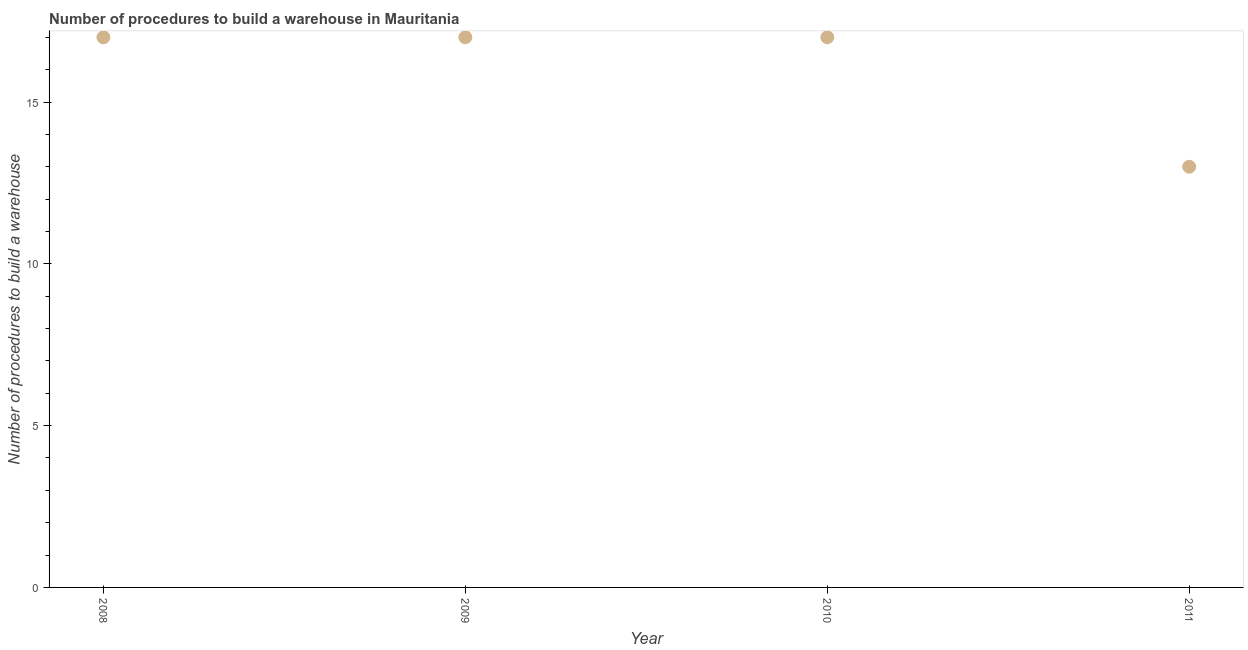What is the number of procedures to build a warehouse in 2009?
Offer a very short reply. 17. Across all years, what is the maximum number of procedures to build a warehouse?
Your answer should be compact. 17. Across all years, what is the minimum number of procedures to build a warehouse?
Offer a very short reply. 13. What is the sum of the number of procedures to build a warehouse?
Your response must be concise. 64. What is the difference between the number of procedures to build a warehouse in 2008 and 2010?
Offer a very short reply. 0. What is the median number of procedures to build a warehouse?
Provide a succinct answer. 17. Do a majority of the years between 2010 and 2008 (inclusive) have number of procedures to build a warehouse greater than 9 ?
Make the answer very short. No. What is the ratio of the number of procedures to build a warehouse in 2009 to that in 2011?
Provide a succinct answer. 1.31. Is the difference between the number of procedures to build a warehouse in 2010 and 2011 greater than the difference between any two years?
Give a very brief answer. Yes. Is the sum of the number of procedures to build a warehouse in 2008 and 2011 greater than the maximum number of procedures to build a warehouse across all years?
Make the answer very short. Yes. What is the difference between the highest and the lowest number of procedures to build a warehouse?
Provide a succinct answer. 4. Does the number of procedures to build a warehouse monotonically increase over the years?
Make the answer very short. No. What is the difference between two consecutive major ticks on the Y-axis?
Your answer should be compact. 5. Are the values on the major ticks of Y-axis written in scientific E-notation?
Provide a short and direct response. No. Does the graph contain any zero values?
Your answer should be very brief. No. Does the graph contain grids?
Provide a short and direct response. No. What is the title of the graph?
Provide a succinct answer. Number of procedures to build a warehouse in Mauritania. What is the label or title of the Y-axis?
Offer a terse response. Number of procedures to build a warehouse. What is the Number of procedures to build a warehouse in 2008?
Ensure brevity in your answer.  17. What is the Number of procedures to build a warehouse in 2011?
Keep it short and to the point. 13. What is the difference between the Number of procedures to build a warehouse in 2008 and 2009?
Make the answer very short. 0. What is the difference between the Number of procedures to build a warehouse in 2008 and 2010?
Your response must be concise. 0. What is the difference between the Number of procedures to build a warehouse in 2009 and 2011?
Your answer should be very brief. 4. What is the difference between the Number of procedures to build a warehouse in 2010 and 2011?
Provide a short and direct response. 4. What is the ratio of the Number of procedures to build a warehouse in 2008 to that in 2009?
Make the answer very short. 1. What is the ratio of the Number of procedures to build a warehouse in 2008 to that in 2011?
Offer a terse response. 1.31. What is the ratio of the Number of procedures to build a warehouse in 2009 to that in 2010?
Ensure brevity in your answer.  1. What is the ratio of the Number of procedures to build a warehouse in 2009 to that in 2011?
Keep it short and to the point. 1.31. What is the ratio of the Number of procedures to build a warehouse in 2010 to that in 2011?
Provide a short and direct response. 1.31. 